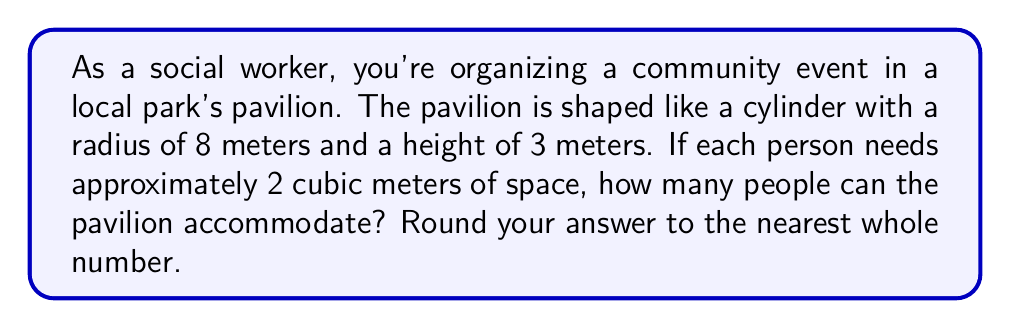Solve this math problem. To solve this problem, we'll follow these steps:

1. Calculate the volume of the cylindrical pavilion:
   The formula for the volume of a cylinder is $V = \pi r^2 h$
   where $r$ is the radius and $h$ is the height.

   $V = \pi \cdot 8^2 \cdot 3$
   $V = \pi \cdot 64 \cdot 3$
   $V = 192\pi$ cubic meters

2. Convert the exact volume to a decimal approximation:
   $V \approx 192 \cdot 3.14159 \approx 603.19$ cubic meters

3. Calculate the number of people that can be accommodated:
   Each person needs 2 cubic meters of space.
   Number of people = Total volume ÷ Space per person
   $N = \frac{603.19}{2} \approx 301.595$

4. Round to the nearest whole number:
   301.595 rounds to 302

Therefore, the pavilion can accommodate approximately 302 people.
Answer: 302 people 